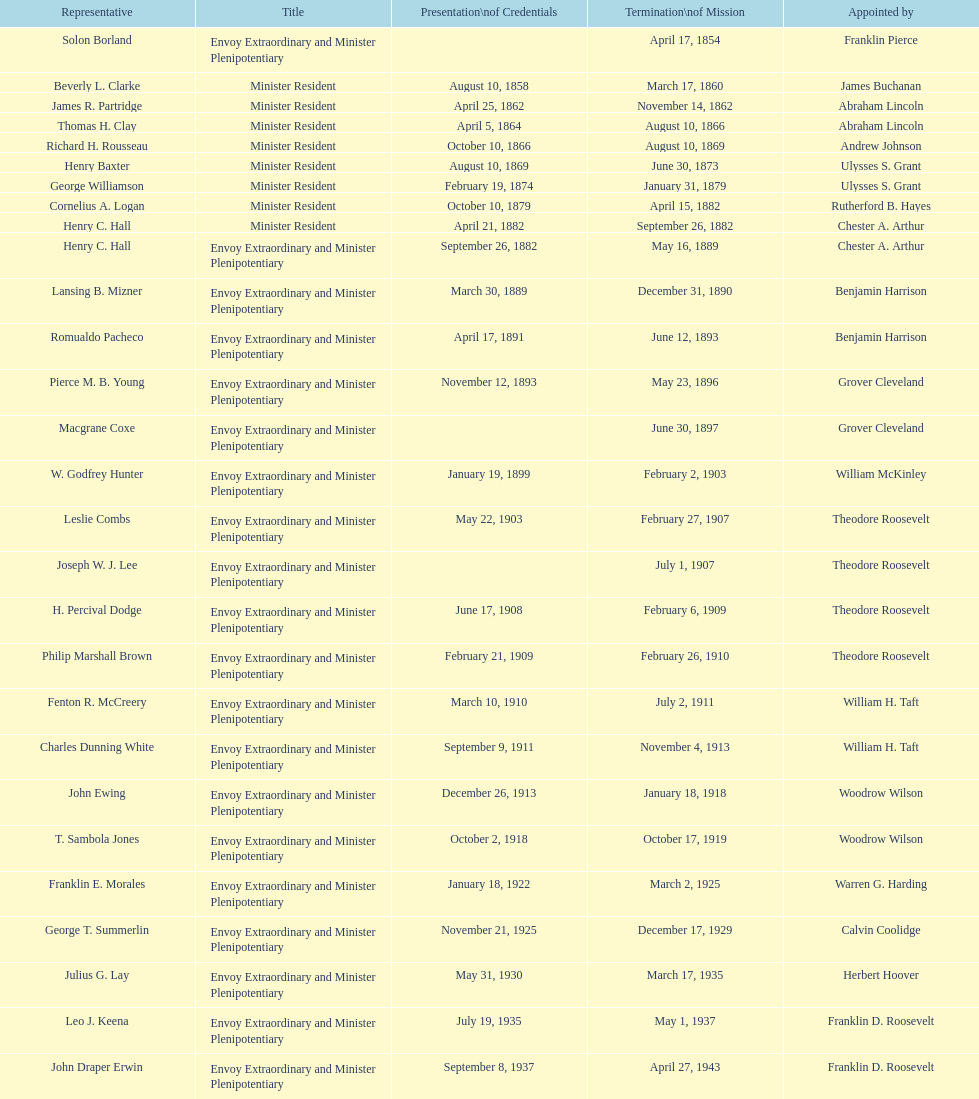Which ambassador to honduras served the longest term? Henry C. Hall. 